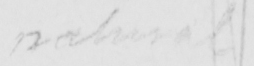Please transcribe the handwritten text in this image. natural 